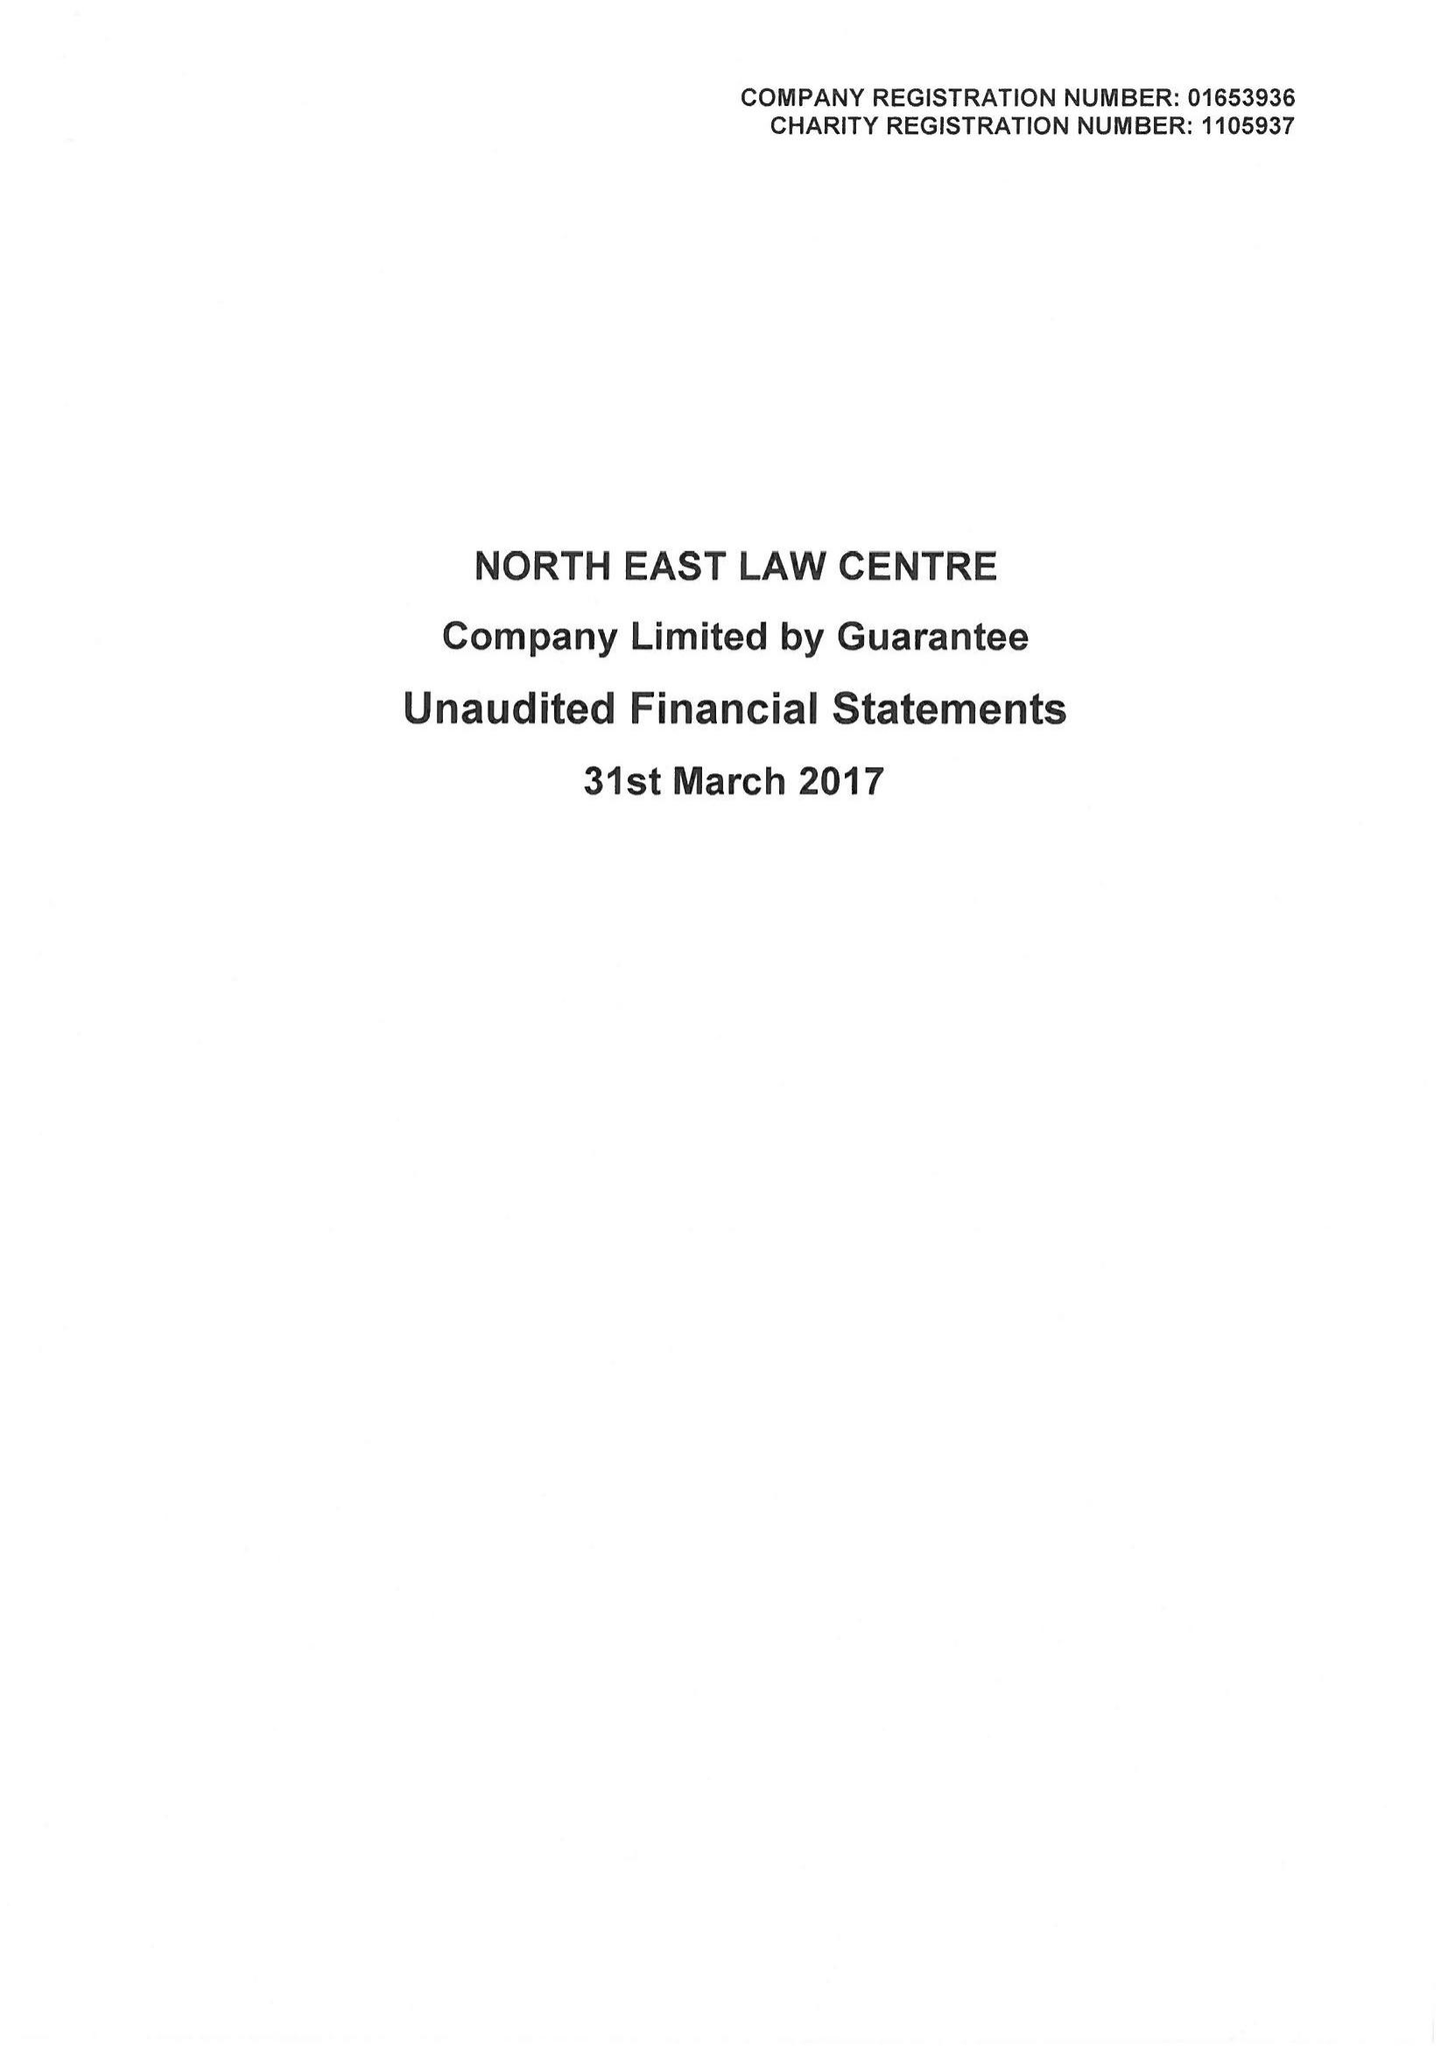What is the value for the address__postcode?
Answer the question using a single word or phrase. NE1 8XS 